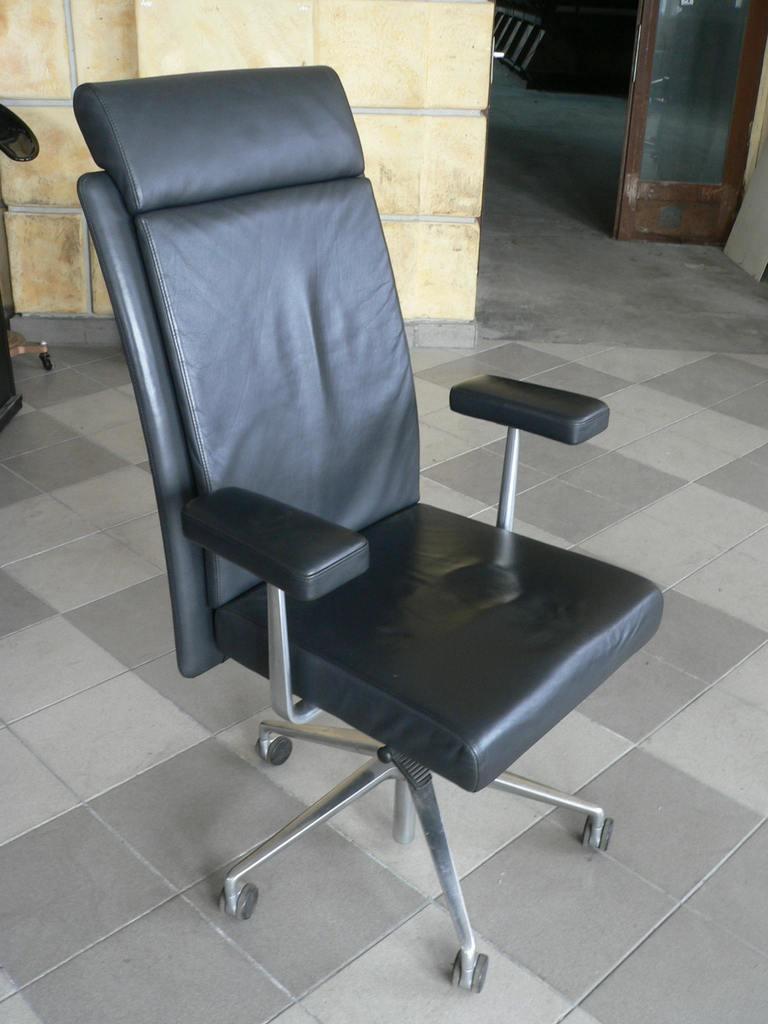Describe this image in one or two sentences. In this image in the middle, there is a chair. At the bottom there is a chair, wall, floor, glass. 